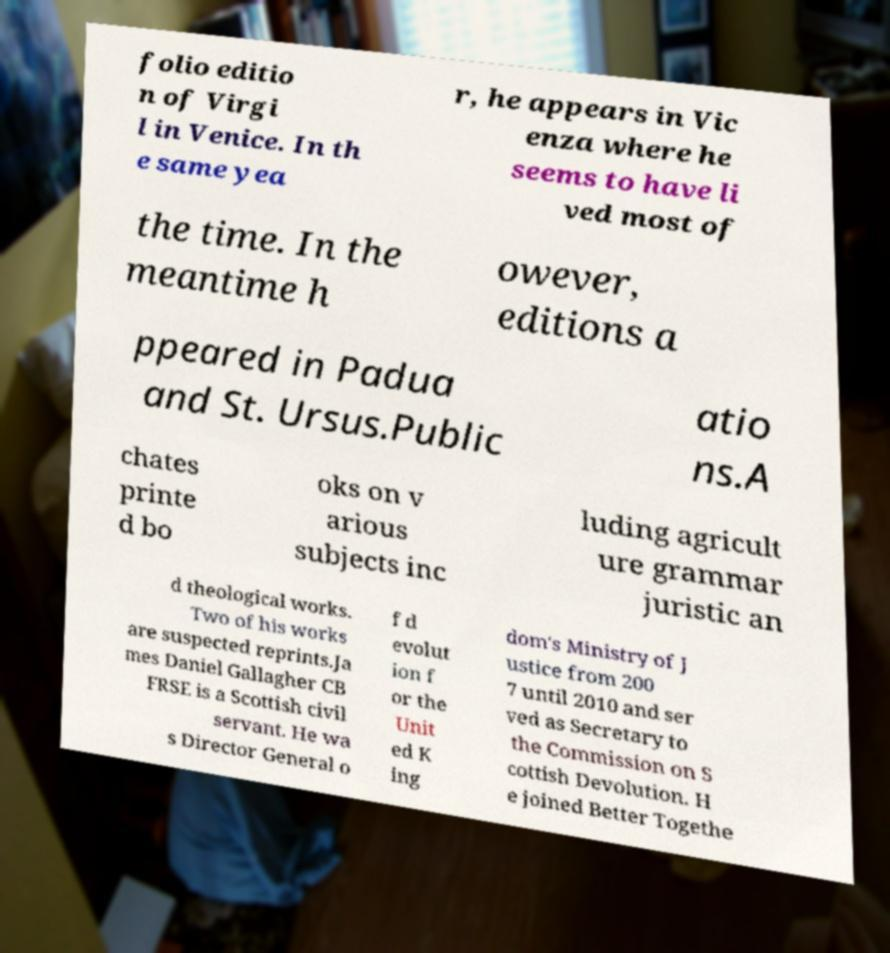I need the written content from this picture converted into text. Can you do that? folio editio n of Virgi l in Venice. In th e same yea r, he appears in Vic enza where he seems to have li ved most of the time. In the meantime h owever, editions a ppeared in Padua and St. Ursus.Public atio ns.A chates printe d bo oks on v arious subjects inc luding agricult ure grammar juristic an d theological works. Two of his works are suspected reprints.Ja mes Daniel Gallagher CB FRSE is a Scottish civil servant. He wa s Director General o f d evolut ion f or the Unit ed K ing dom's Ministry of J ustice from 200 7 until 2010 and ser ved as Secretary to the Commission on S cottish Devolution. H e joined Better Togethe 